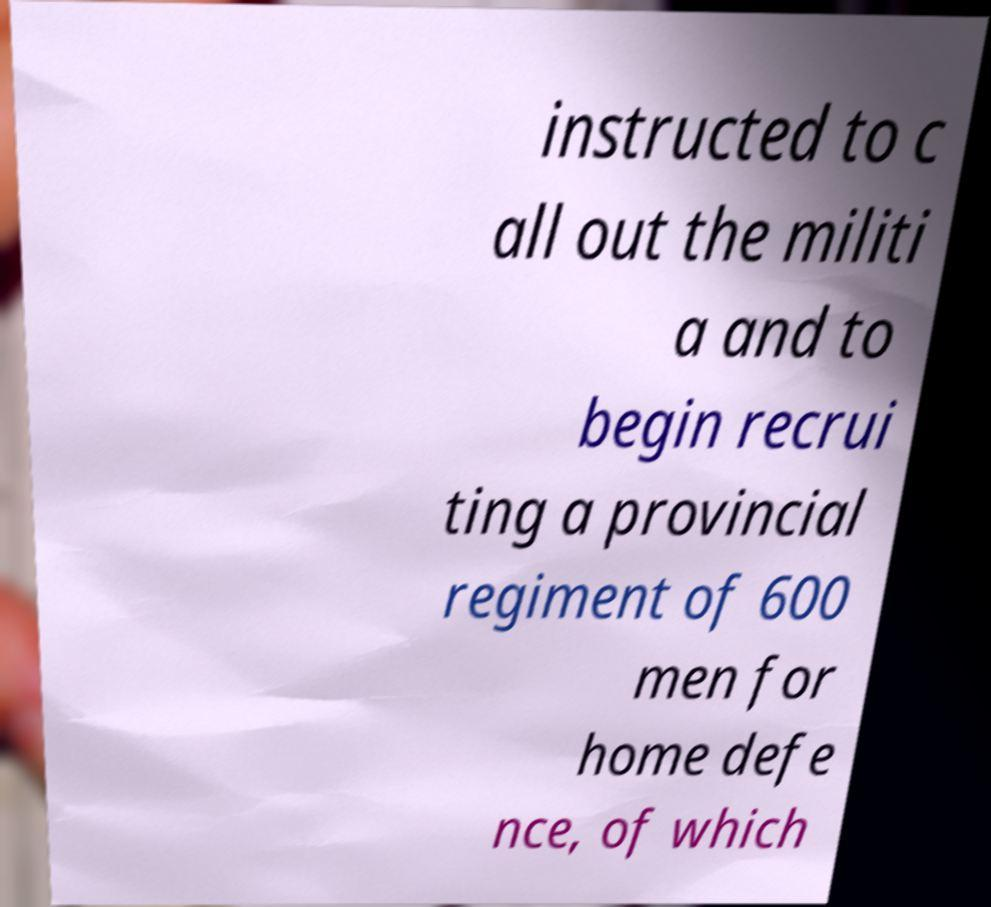Can you read and provide the text displayed in the image?This photo seems to have some interesting text. Can you extract and type it out for me? instructed to c all out the militi a and to begin recrui ting a provincial regiment of 600 men for home defe nce, of which 